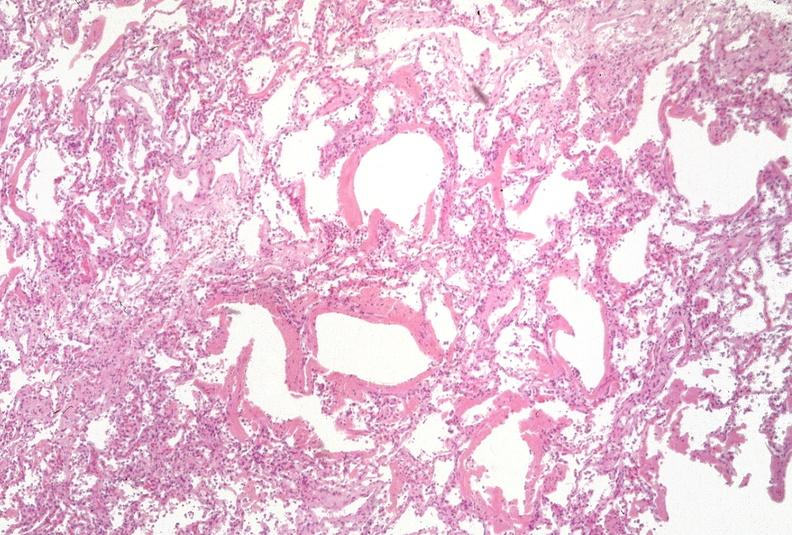what does this image show?
Answer the question using a single word or phrase. Lung 